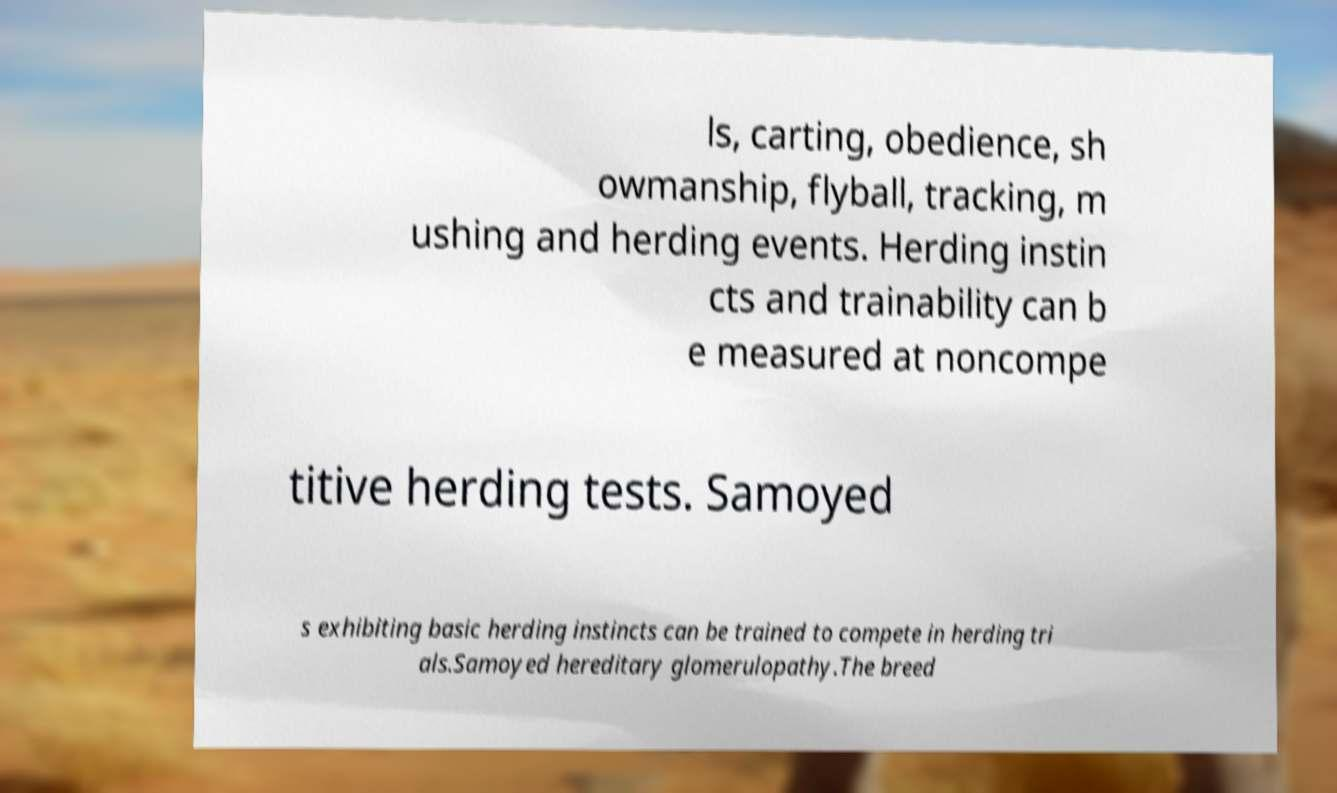I need the written content from this picture converted into text. Can you do that? ls, carting, obedience, sh owmanship, flyball, tracking, m ushing and herding events. Herding instin cts and trainability can b e measured at noncompe titive herding tests. Samoyed s exhibiting basic herding instincts can be trained to compete in herding tri als.Samoyed hereditary glomerulopathy.The breed 